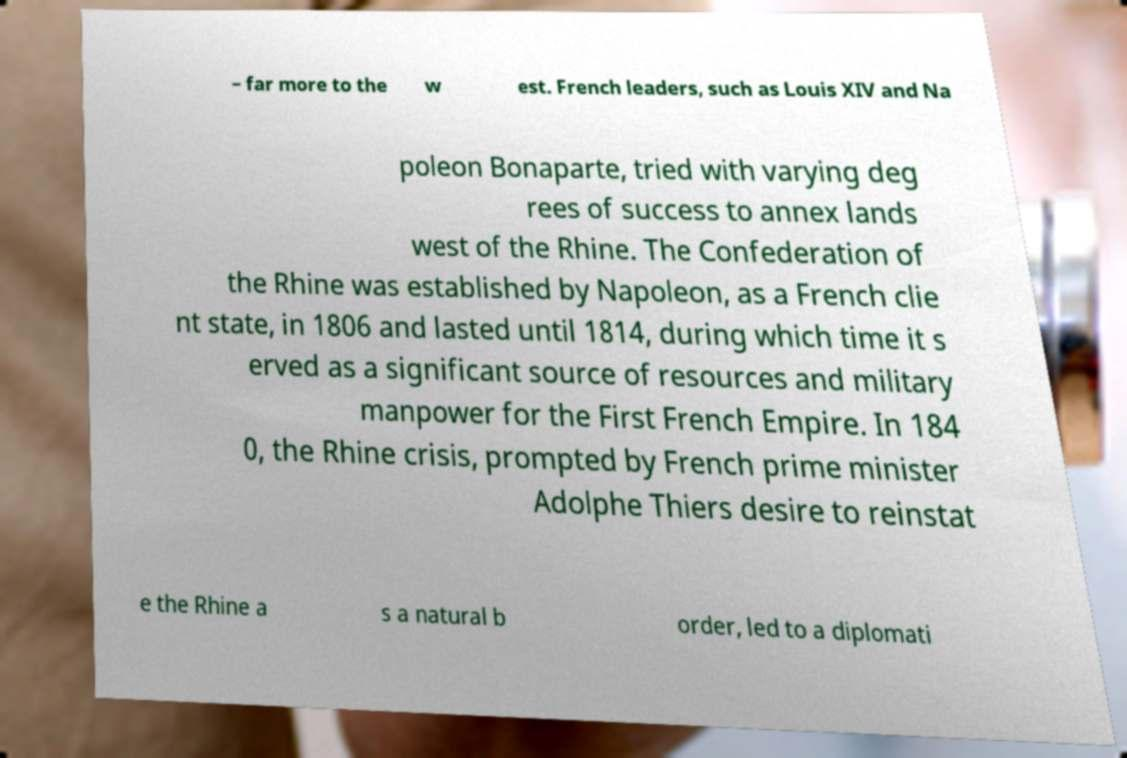I need the written content from this picture converted into text. Can you do that? – far more to the w est. French leaders, such as Louis XIV and Na poleon Bonaparte, tried with varying deg rees of success to annex lands west of the Rhine. The Confederation of the Rhine was established by Napoleon, as a French clie nt state, in 1806 and lasted until 1814, during which time it s erved as a significant source of resources and military manpower for the First French Empire. In 184 0, the Rhine crisis, prompted by French prime minister Adolphe Thiers desire to reinstat e the Rhine a s a natural b order, led to a diplomati 